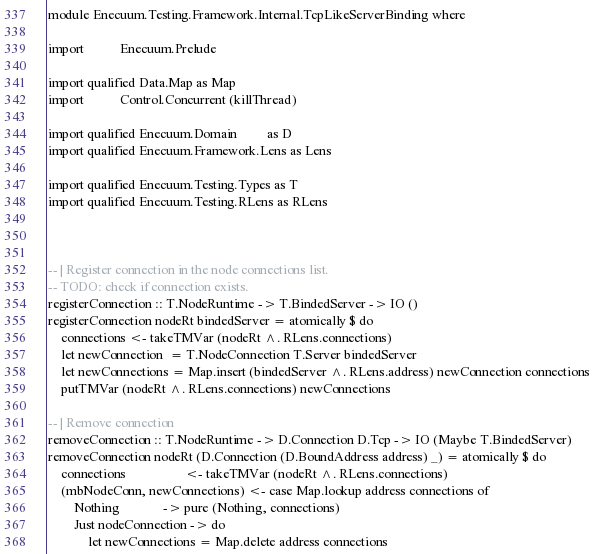<code> <loc_0><loc_0><loc_500><loc_500><_Haskell_>module Enecuum.Testing.Framework.Internal.TcpLikeServerBinding where

import           Enecuum.Prelude

import qualified Data.Map as Map
import           Control.Concurrent (killThread)

import qualified Enecuum.Domain         as D
import qualified Enecuum.Framework.Lens as Lens

import qualified Enecuum.Testing.Types as T
import qualified Enecuum.Testing.RLens as RLens



-- | Register connection in the node connections list.
-- TODO: check if connection exists.
registerConnection :: T.NodeRuntime -> T.BindedServer -> IO ()
registerConnection nodeRt bindedServer = atomically $ do
    connections <- takeTMVar (nodeRt ^. RLens.connections)
    let newConnection  = T.NodeConnection T.Server bindedServer
    let newConnections = Map.insert (bindedServer ^. RLens.address) newConnection connections
    putTMVar (nodeRt ^. RLens.connections) newConnections

-- | Remove connection
removeConnection :: T.NodeRuntime -> D.Connection D.Tcp -> IO (Maybe T.BindedServer)
removeConnection nodeRt (D.Connection (D.BoundAddress address) _) = atomically $ do
    connections                  <- takeTMVar (nodeRt ^. RLens.connections)
    (mbNodeConn, newConnections) <- case Map.lookup address connections of
        Nothing             -> pure (Nothing, connections)
        Just nodeConnection -> do
            let newConnections = Map.delete address connections</code> 